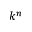<formula> <loc_0><loc_0><loc_500><loc_500>k ^ { n }</formula> 